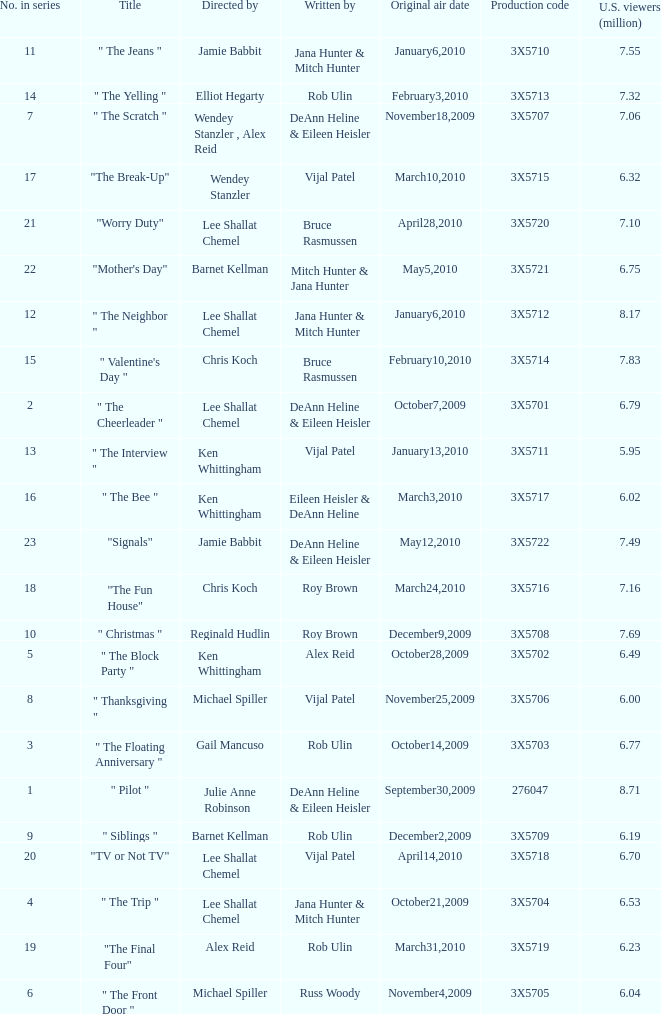Parse the full table. {'header': ['No. in series', 'Title', 'Directed by', 'Written by', 'Original air date', 'Production code', 'U.S. viewers (million)'], 'rows': [['11', '" The Jeans "', 'Jamie Babbit', 'Jana Hunter & Mitch Hunter', 'January6,2010', '3X5710', '7.55'], ['14', '" The Yelling "', 'Elliot Hegarty', 'Rob Ulin', 'February3,2010', '3X5713', '7.32'], ['7', '" The Scratch "', 'Wendey Stanzler , Alex Reid', 'DeAnn Heline & Eileen Heisler', 'November18,2009', '3X5707', '7.06'], ['17', '"The Break-Up"', 'Wendey Stanzler', 'Vijal Patel', 'March10,2010', '3X5715', '6.32'], ['21', '"Worry Duty"', 'Lee Shallat Chemel', 'Bruce Rasmussen', 'April28,2010', '3X5720', '7.10'], ['22', '"Mother\'s Day"', 'Barnet Kellman', 'Mitch Hunter & Jana Hunter', 'May5,2010', '3X5721', '6.75'], ['12', '" The Neighbor "', 'Lee Shallat Chemel', 'Jana Hunter & Mitch Hunter', 'January6,2010', '3X5712', '8.17'], ['15', '" Valentine\'s Day "', 'Chris Koch', 'Bruce Rasmussen', 'February10,2010', '3X5714', '7.83'], ['2', '" The Cheerleader "', 'Lee Shallat Chemel', 'DeAnn Heline & Eileen Heisler', 'October7,2009', '3X5701', '6.79'], ['13', '" The Interview "', 'Ken Whittingham', 'Vijal Patel', 'January13,2010', '3X5711', '5.95'], ['16', '" The Bee "', 'Ken Whittingham', 'Eileen Heisler & DeAnn Heline', 'March3,2010', '3X5717', '6.02'], ['23', '"Signals"', 'Jamie Babbit', 'DeAnn Heline & Eileen Heisler', 'May12,2010', '3X5722', '7.49'], ['18', '"The Fun House"', 'Chris Koch', 'Roy Brown', 'March24,2010', '3X5716', '7.16'], ['10', '" Christmas "', 'Reginald Hudlin', 'Roy Brown', 'December9,2009', '3X5708', '7.69'], ['5', '" The Block Party "', 'Ken Whittingham', 'Alex Reid', 'October28,2009', '3X5702', '6.49'], ['8', '" Thanksgiving "', 'Michael Spiller', 'Vijal Patel', 'November25,2009', '3X5706', '6.00'], ['3', '" The Floating Anniversary "', 'Gail Mancuso', 'Rob Ulin', 'October14,2009', '3X5703', '6.77'], ['1', '" Pilot "', 'Julie Anne Robinson', 'DeAnn Heline & Eileen Heisler', 'September30,2009', '276047', '8.71'], ['9', '" Siblings "', 'Barnet Kellman', 'Rob Ulin', 'December2,2009', '3X5709', '6.19'], ['20', '"TV or Not TV"', 'Lee Shallat Chemel', 'Vijal Patel', 'April14,2010', '3X5718', '6.70'], ['4', '" The Trip "', 'Lee Shallat Chemel', 'Jana Hunter & Mitch Hunter', 'October21,2009', '3X5704', '6.53'], ['19', '"The Final Four"', 'Alex Reid', 'Rob Ulin', 'March31,2010', '3X5719', '6.23'], ['6', '" The Front Door "', 'Michael Spiller', 'Russ Woody', 'November4,2009', '3X5705', '6.04']]} How many million U.S. viewers saw the episode with production code 3X5710? 7.55. 